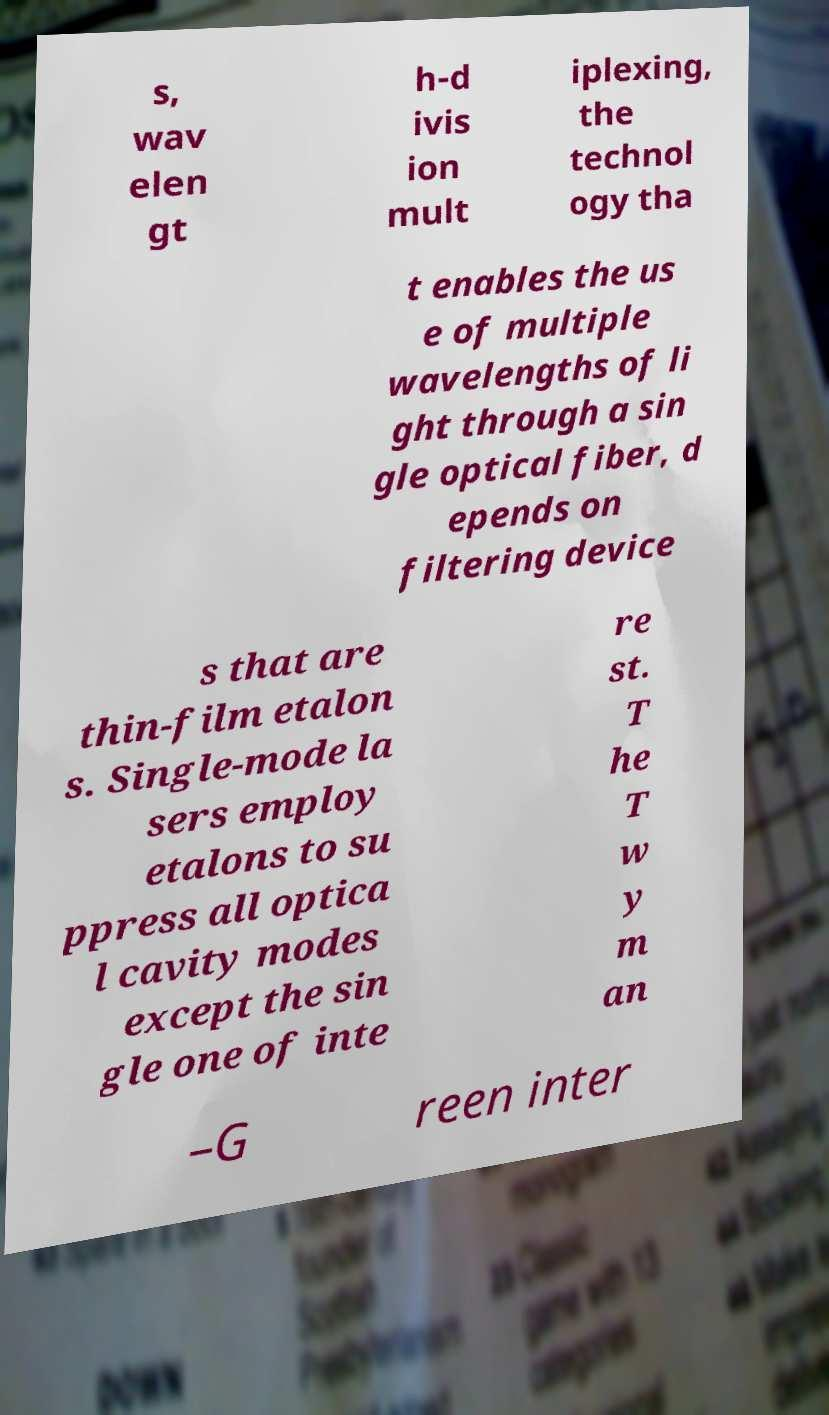What messages or text are displayed in this image? I need them in a readable, typed format. s, wav elen gt h-d ivis ion mult iplexing, the technol ogy tha t enables the us e of multiple wavelengths of li ght through a sin gle optical fiber, d epends on filtering device s that are thin-film etalon s. Single-mode la sers employ etalons to su ppress all optica l cavity modes except the sin gle one of inte re st. T he T w y m an –G reen inter 